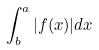<formula> <loc_0><loc_0><loc_500><loc_500>\int _ { b } ^ { a } | f ( x ) | d x</formula> 